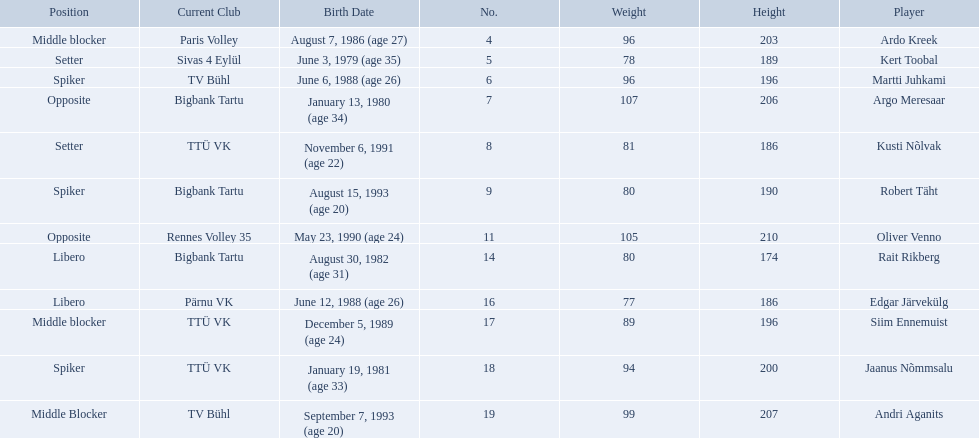Who are the players of the estonian men's national volleyball team? Ardo Kreek, Kert Toobal, Martti Juhkami, Argo Meresaar, Kusti Nõlvak, Robert Täht, Oliver Venno, Rait Rikberg, Edgar Järvekülg, Siim Ennemuist, Jaanus Nõmmsalu, Andri Aganits. Of these, which have a height over 200? Ardo Kreek, Argo Meresaar, Oliver Venno, Andri Aganits. Of the remaining, who is the tallest? Oliver Venno. 